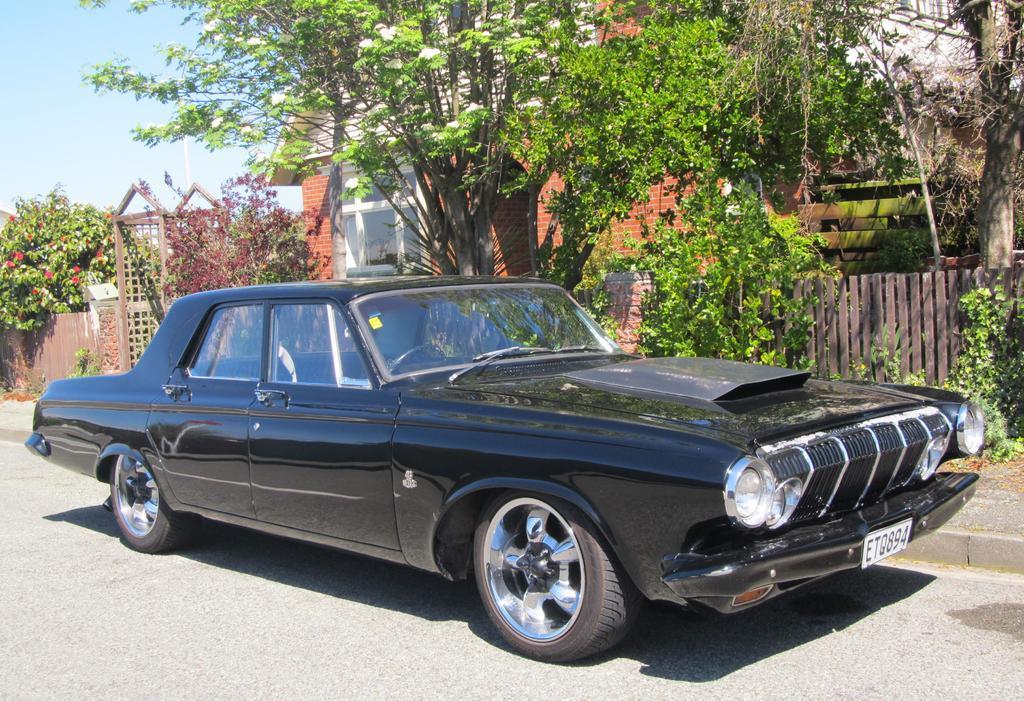In one or two sentences, can you explain what this image depicts? In this image I can see few trees, house, windows, few red color flowers, fencing and black color car on the road. The sky is in blue and white color. 